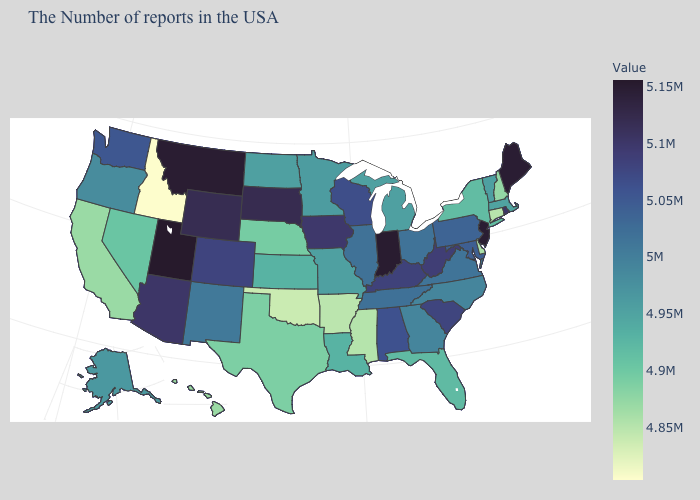Which states hav the highest value in the Northeast?
Write a very short answer. Maine. Which states have the highest value in the USA?
Answer briefly. Utah. Is the legend a continuous bar?
Quick response, please. Yes. Does South Carolina have the highest value in the USA?
Answer briefly. No. 